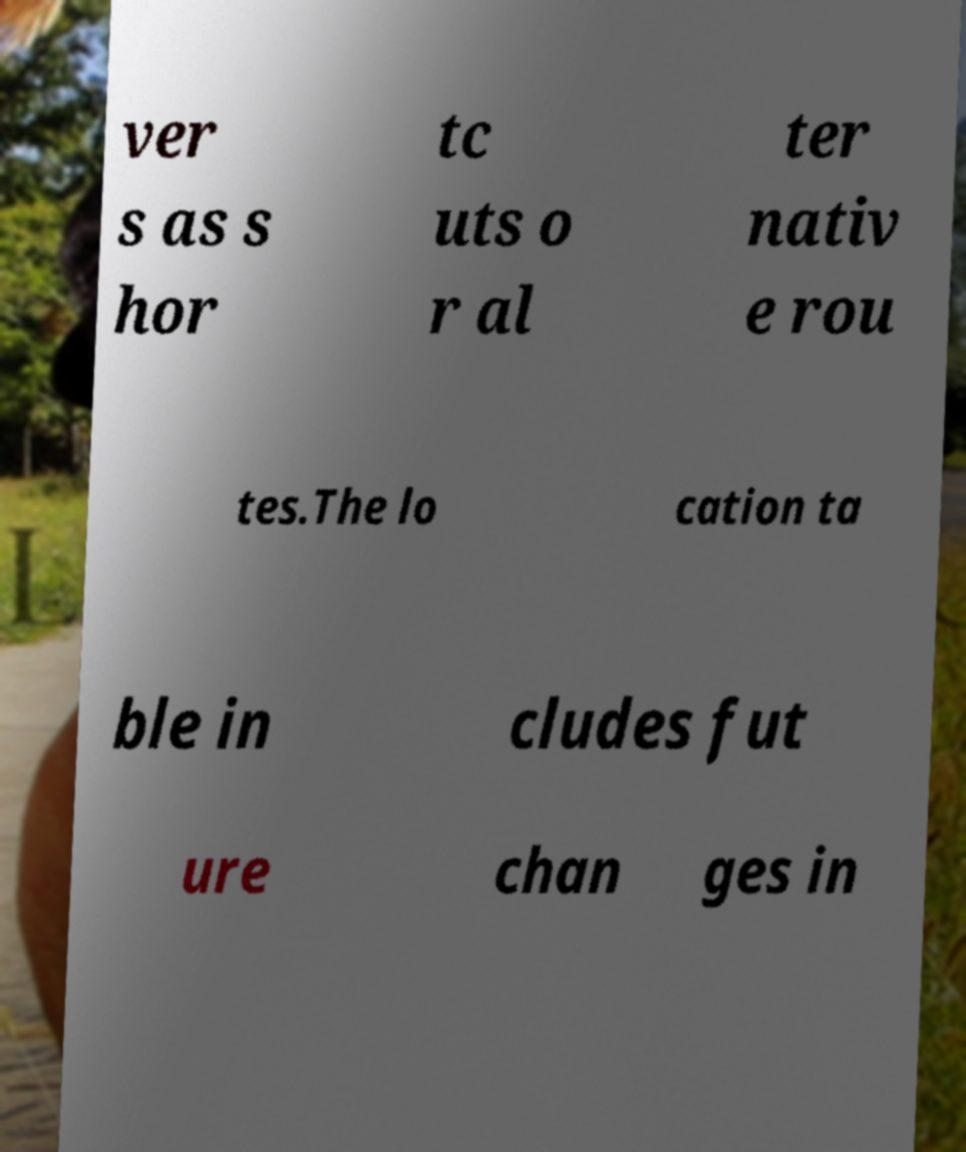Can you accurately transcribe the text from the provided image for me? ver s as s hor tc uts o r al ter nativ e rou tes.The lo cation ta ble in cludes fut ure chan ges in 